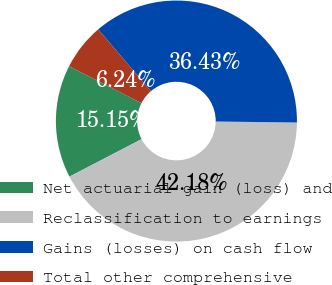Convert chart. <chart><loc_0><loc_0><loc_500><loc_500><pie_chart><fcel>Net actuarial gain (loss) and<fcel>Reclassification to earnings<fcel>Gains (losses) on cash flow<fcel>Total other comprehensive<nl><fcel>15.15%<fcel>42.18%<fcel>36.43%<fcel>6.24%<nl></chart> 